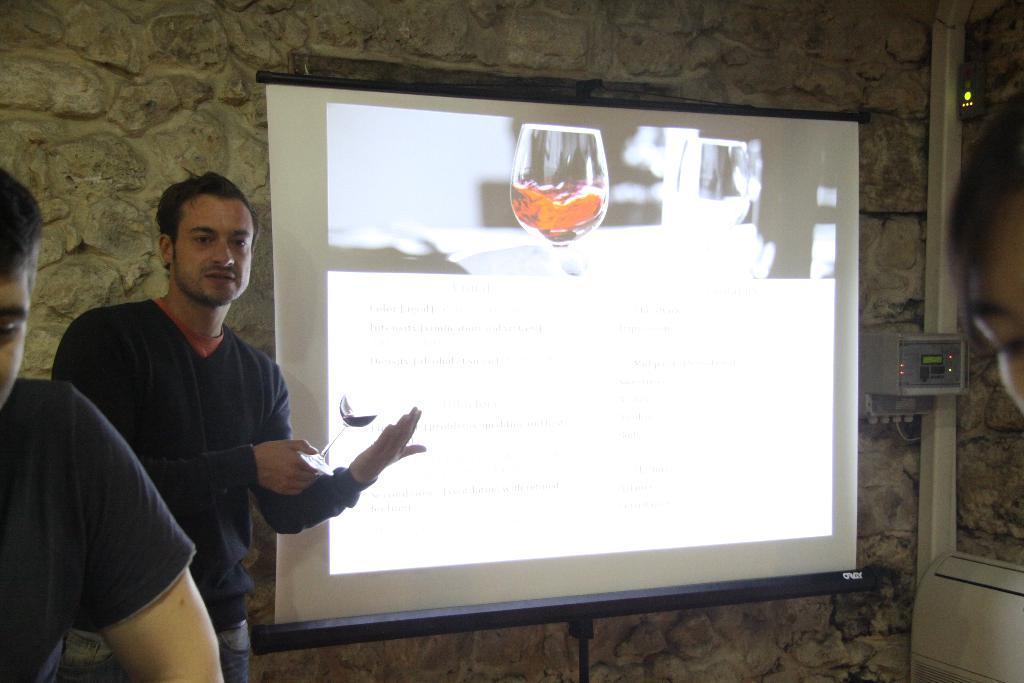Could you give a brief overview of what you see in this image? In the picture I can see two men are standing on the ground. Here I can see a projector screen. On the screen I can see a glass and some other things are displaying on it. The projector screen is attached to the wall. 